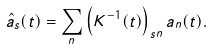<formula> <loc_0><loc_0><loc_500><loc_500>\hat { a } _ { s } ( t ) = \sum _ { n } \left ( { K } ^ { - 1 } ( t ) \right ) _ { s n } a _ { n } ( t ) .</formula> 